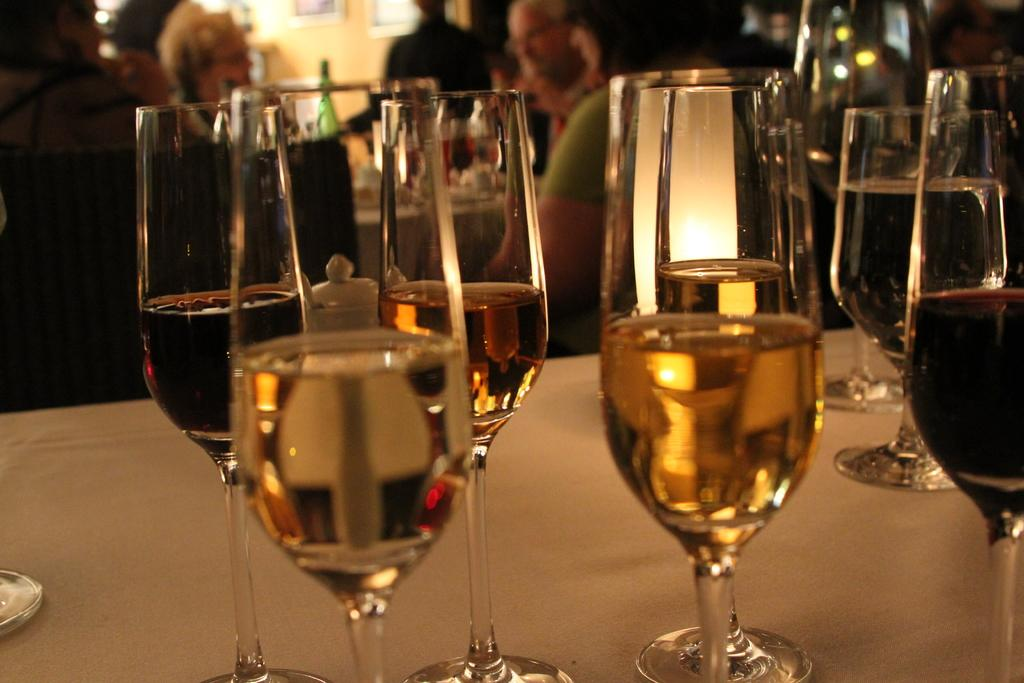What type of bottles are on the table in the image? There are wine glass bottles on the table. Can you describe the people in the image? There is a group of people standing behind the bottles. What type of competition is taking place between the baseball players in the image? There are no baseball players or competition present in the image; it features wine glass bottles and a group of people standing behind them. 